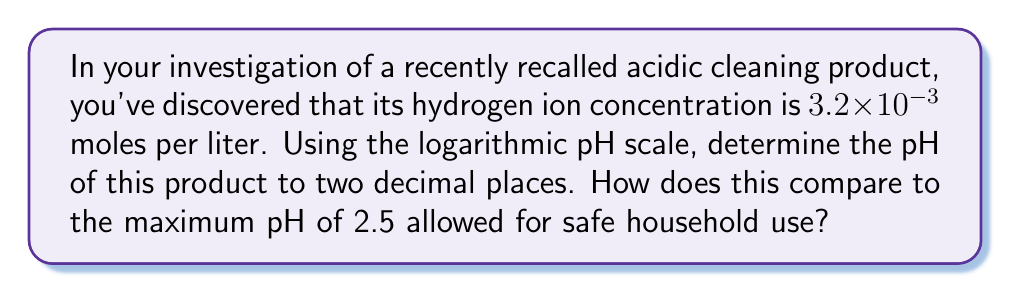Give your solution to this math problem. To solve this problem, we'll use the definition of pH and logarithmic properties:

1) The pH is defined as the negative logarithm (base 10) of the hydrogen ion concentration [H+]:

   $$ pH = -\log_{10}[H^+] $$

2) We're given that [H+] = $3.2 \times 10^{-3}$ mol/L. Let's substitute this into our equation:

   $$ pH = -\log_{10}(3.2 \times 10^{-3}) $$

3) Using the properties of logarithms, we can split this into two parts:

   $$ pH = -(\log_{10}(3.2) + \log_{10}(10^{-3})) $$

4) Simplify the second part:

   $$ pH = -(\log_{10}(3.2) - 3) $$

5) Calculate $\log_{10}(3.2)$ using a calculator: $\log_{10}(3.2) \approx 0.5051$

6) Substitute and calculate:

   $$ pH = -(0.5051 - 3) = 2.4949 $$

7) Rounding to two decimal places:

   $$ pH = 2.49 $$

8) Compare to the maximum allowed pH of 2.5:
   2.49 is less than 2.5, so the product's pH is within the allowed range, but only barely.
Answer: pH = 2.49; within allowed range 